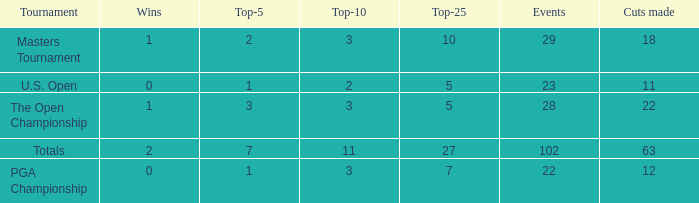How many vuts made for a player with 2 wins and under 7 top 5s? None. 